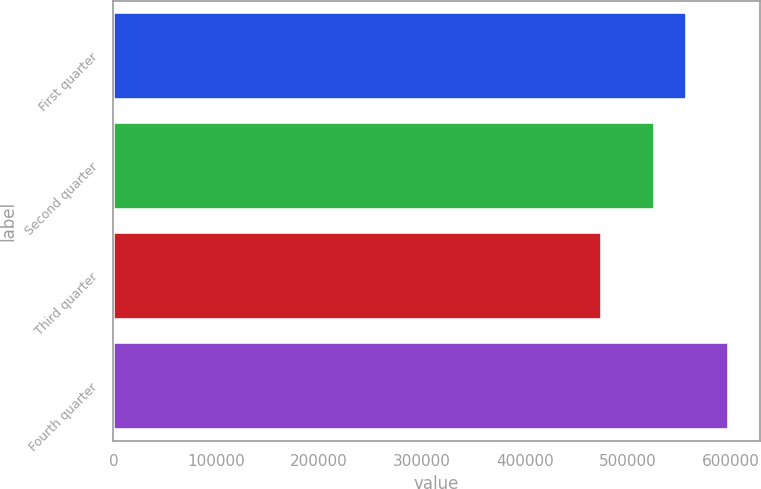Convert chart. <chart><loc_0><loc_0><loc_500><loc_500><bar_chart><fcel>First quarter<fcel>Second quarter<fcel>Third quarter<fcel>Fourth quarter<nl><fcel>558011<fcel>526359<fcel>475285<fcel>598520<nl></chart> 